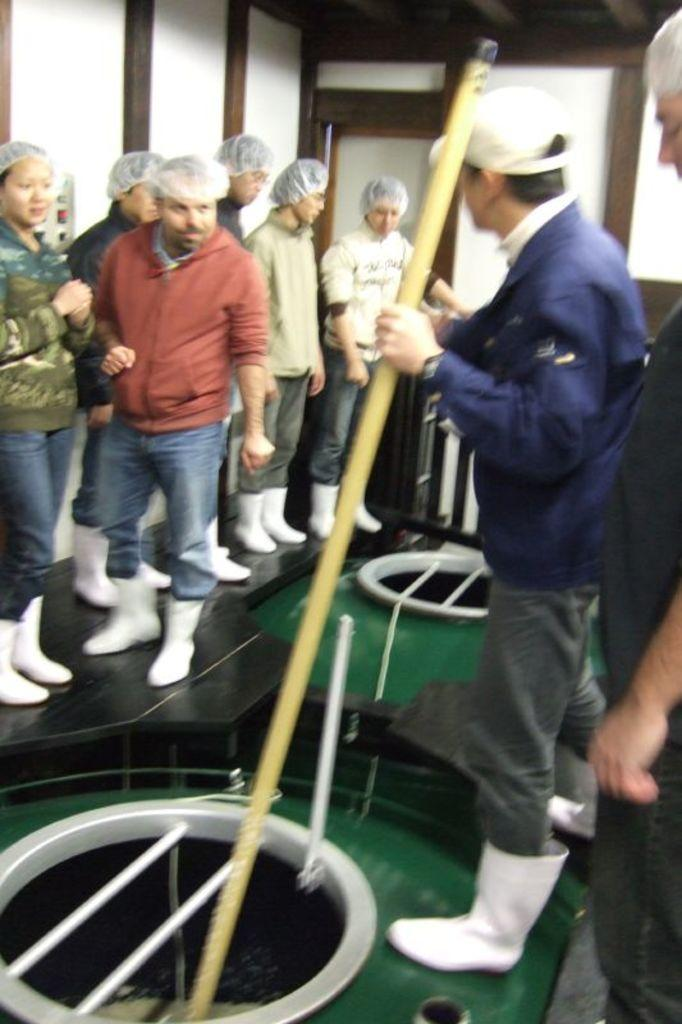What is happening in the image? There are people standing in the image. What can be seen in the background of the image? There is a wall in the background of the image. What type of dinner is being served in the image? There is no dinner present in the image; it only features people standing and a wall in the background. 